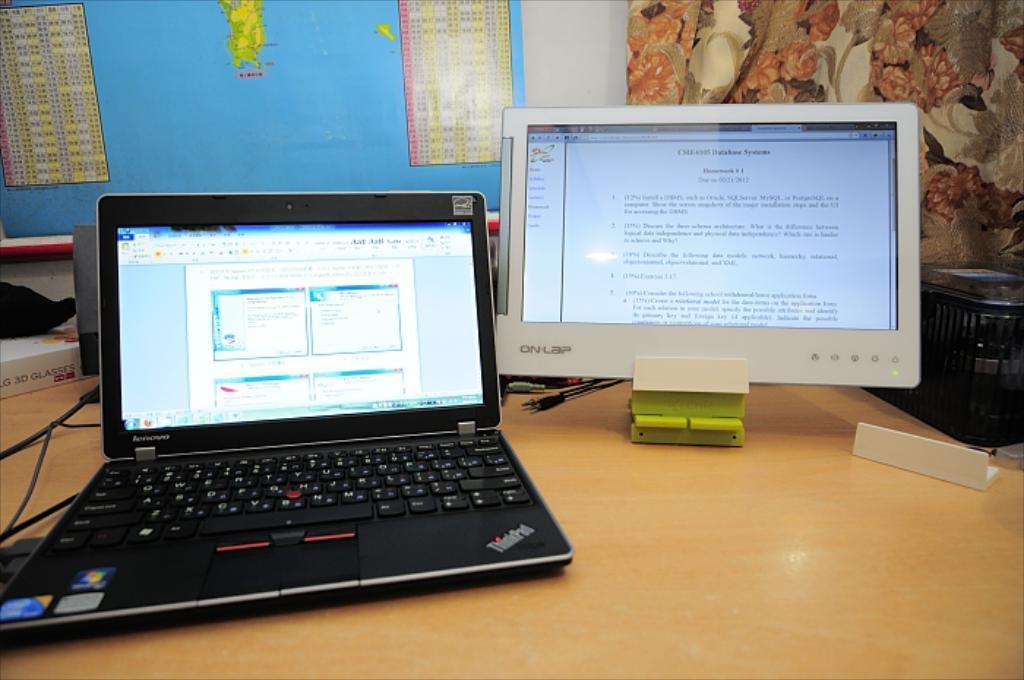How would you summarize this image in a sentence or two? In this picture there is a laptop at the left side of the image and a display screen at the right side of the image, there is curtain at the right side of the image, the laptop is placed on the table. 